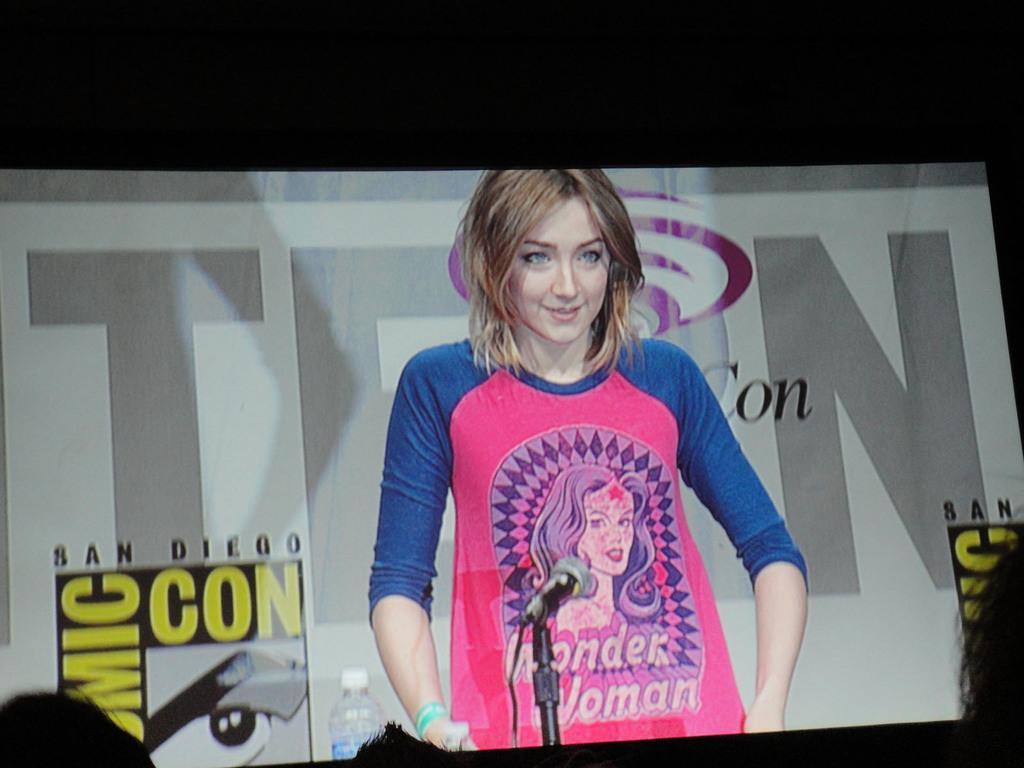Describe this image in one or two sentences. In this picture there is a view of the projector screen in which a girl is standing at the speech desk, wearing blue and pink color t- shirt. 